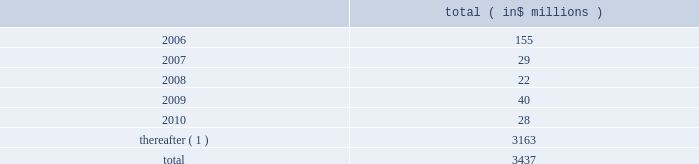Celanese corporation and subsidiaries notes to consolidated financial statements ( continued ) 2022 amend certain material agreements governing bcp crystal 2019s indebtedness ; 2022 change the business conducted by celanese holdings and its subsidiaries ; and 2022 enter into hedging agreements that restrict dividends from subsidiaries .
In addition , the senior credit facilities require bcp crystal to maintain the following financial covenants : a maximum total leverage ratio , a maximum bank debt leverage ratio , a minimum interest coverage ratio and maximum capital expenditures limitation .
The maximum consolidated net bank debt to adjusted ebitda ratio , as defined , previously required under the senior credit facilities , was eliminated when the company amended the facilities in january 2005 .
As of december 31 , 2005 , the company was in compliance with all of the financial covenants related to its debt agreements .
The maturation of the company 2019s debt , including short term borrowings , is as follows : ( in $ millions ) .
( 1 ) includes $ 2 million purchase accounting adjustment to assumed debt .
17 .
Benefit obligations pension obligations .
Pension obligations are established for benefits payable in the form of retirement , disability and surviving dependent pensions .
The benefits offered vary according to the legal , fiscal and economic conditions of each country .
The commitments result from participation in defined contribution and defined benefit plans , primarily in the u.s .
Benefits are dependent on years of service and the employee 2019s compensation .
Supplemental retirement benefits provided to certain employees are non-qualified for u.s .
Tax purposes .
Separate trusts have been established for some non-qualified plans .
Defined benefit pension plans exist at certain locations in north america and europe .
As of december 31 , 2005 , the company 2019s u.s .
Qualified pension plan represented greater than 85% ( 85 % ) and 75% ( 75 % ) of celanese 2019s pension plan assets and liabilities , respectively .
Independent trusts or insurance companies administer the majority of these plans .
Actuarial valuations for these plans are prepared annually .
The company sponsors various defined contribution plans in europe and north america covering certain employees .
Employees may contribute to these plans and the company will match these contributions in varying amounts .
Contributions to the defined contribution plans are based on specified percentages of employee contributions and they aggregated $ 12 million for the year ended decem- ber 31 , 2005 , $ 8 million for the nine months ended december 31 , 2004 , $ 3 million for the three months ended march 31 , 2004 and $ 11 million for the year ended december 31 , 2003 .
In connection with the acquisition of cag , the purchaser agreed to pre-fund $ 463 million of certain pension obligations .
During the nine months ended december 31 , 2004 , $ 409 million was pre-funded to the company 2019s pension plans .
The company contributed an additional $ 54 million to the non-qualified pension plan 2019s rabbi trusts in february 2005 .
In connection with the company 2019s acquisition of vinamul and acetex , the company assumed certain assets and obligations related to the acquired pension plans .
The company recorded liabilities of $ 128 million for these pension plans .
Total pension assets acquired amounted to $ 85 million. .
What is average of the debt maturities that will occur in the period from 2006 to 2010 in millions? 
Rationale: the average is the the sum of the amounts divided by the number of periods
Computations: ((3437 - 3163) / 5)
Answer: 54.8. 